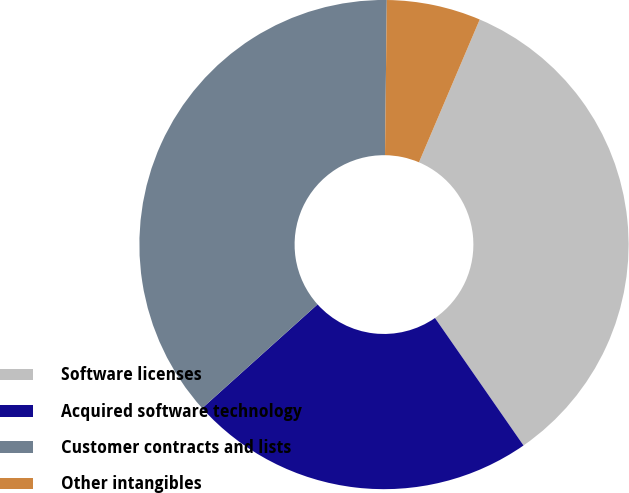<chart> <loc_0><loc_0><loc_500><loc_500><pie_chart><fcel>Software licenses<fcel>Acquired software technology<fcel>Customer contracts and lists<fcel>Other intangibles<nl><fcel>33.94%<fcel>23.0%<fcel>36.85%<fcel>6.22%<nl></chart> 